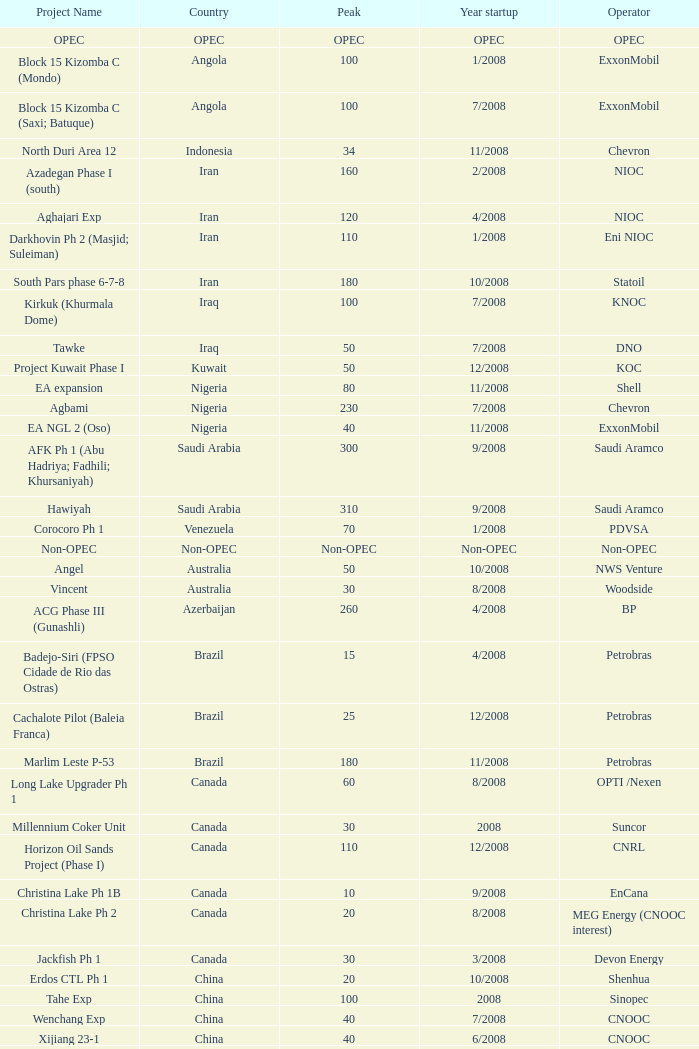What is the Peak with a Project Name that is talakan ph 1? 60.0. 